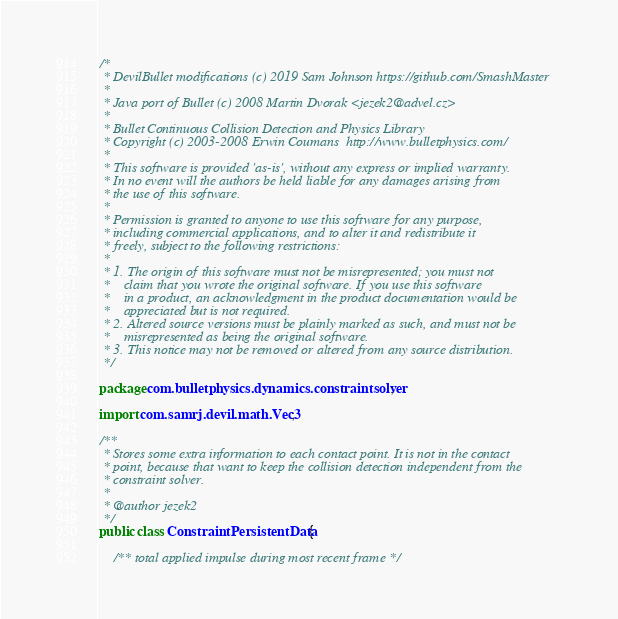Convert code to text. <code><loc_0><loc_0><loc_500><loc_500><_Java_>/*
 * DevilBullet modifications (c) 2019 Sam Johnson https://github.com/SmashMaster
 * 
 * Java port of Bullet (c) 2008 Martin Dvorak <jezek2@advel.cz>
 *
 * Bullet Continuous Collision Detection and Physics Library
 * Copyright (c) 2003-2008 Erwin Coumans  http://www.bulletphysics.com/
 *
 * This software is provided 'as-is', without any express or implied warranty.
 * In no event will the authors be held liable for any damages arising from
 * the use of this software.
 * 
 * Permission is granted to anyone to use this software for any purpose, 
 * including commercial applications, and to alter it and redistribute it
 * freely, subject to the following restrictions:
 * 
 * 1. The origin of this software must not be misrepresented; you must not
 *    claim that you wrote the original software. If you use this software
 *    in a product, an acknowledgment in the product documentation would be
 *    appreciated but is not required.
 * 2. Altered source versions must be plainly marked as such, and must not be
 *    misrepresented as being the original software.
 * 3. This notice may not be removed or altered from any source distribution.
 */

package com.bulletphysics.dynamics.constraintsolver;

import com.samrj.devil.math.Vec3;

/**
 * Stores some extra information to each contact point. It is not in the contact
 * point, because that want to keep the collision detection independent from the
 * constraint solver.
 * 
 * @author jezek2
 */
public class ConstraintPersistentData {
	
	/** total applied impulse during most recent frame */</code> 